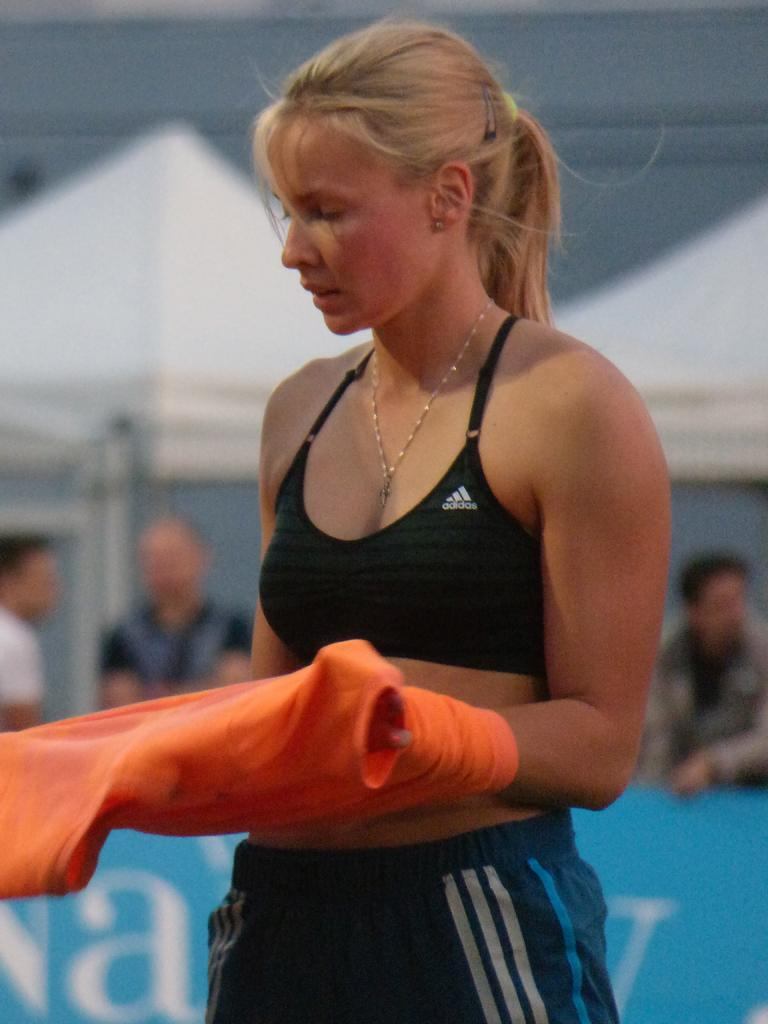Who is present in the image? There is a woman in the image. What is the woman wearing? The woman is wearing black sportswear. What is the woman holding in the image? The woman is holding an orange T-shirt. What type of celery is the woman eating in the image? There is no celery present in the image, and the woman is not eating anything. Can you see a rabbit or a goat in the image? No, there are no rabbits or goats present in the image. 